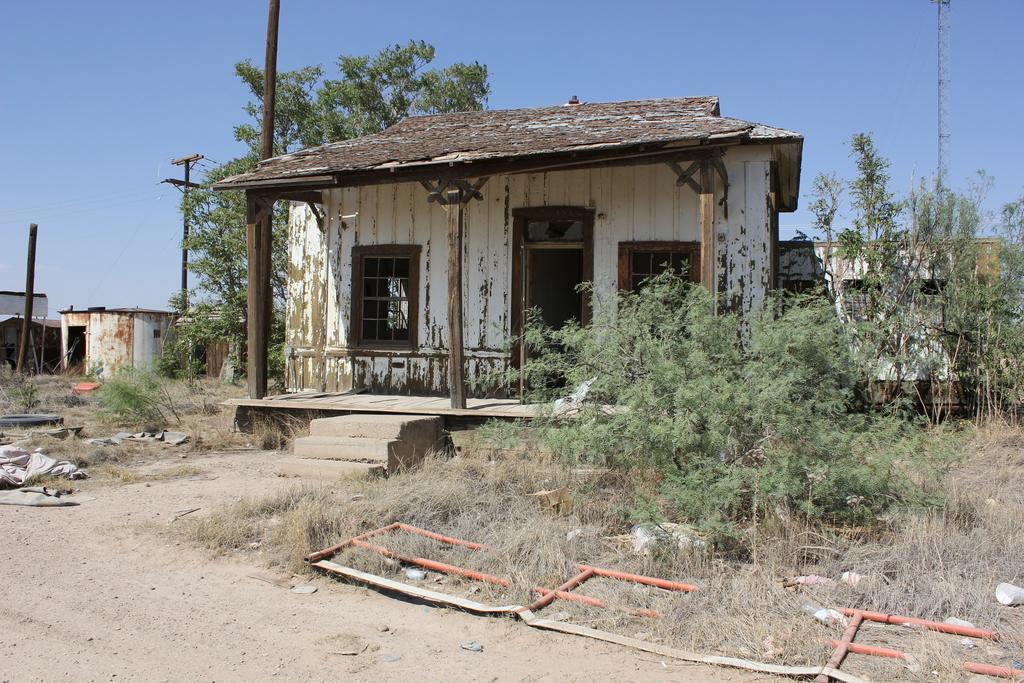In one or two sentences, can you explain what this image depicts? In this image we can see the houses, there are some poles, trees, grass, windows and some other objects, in the background, we can see the sky. 